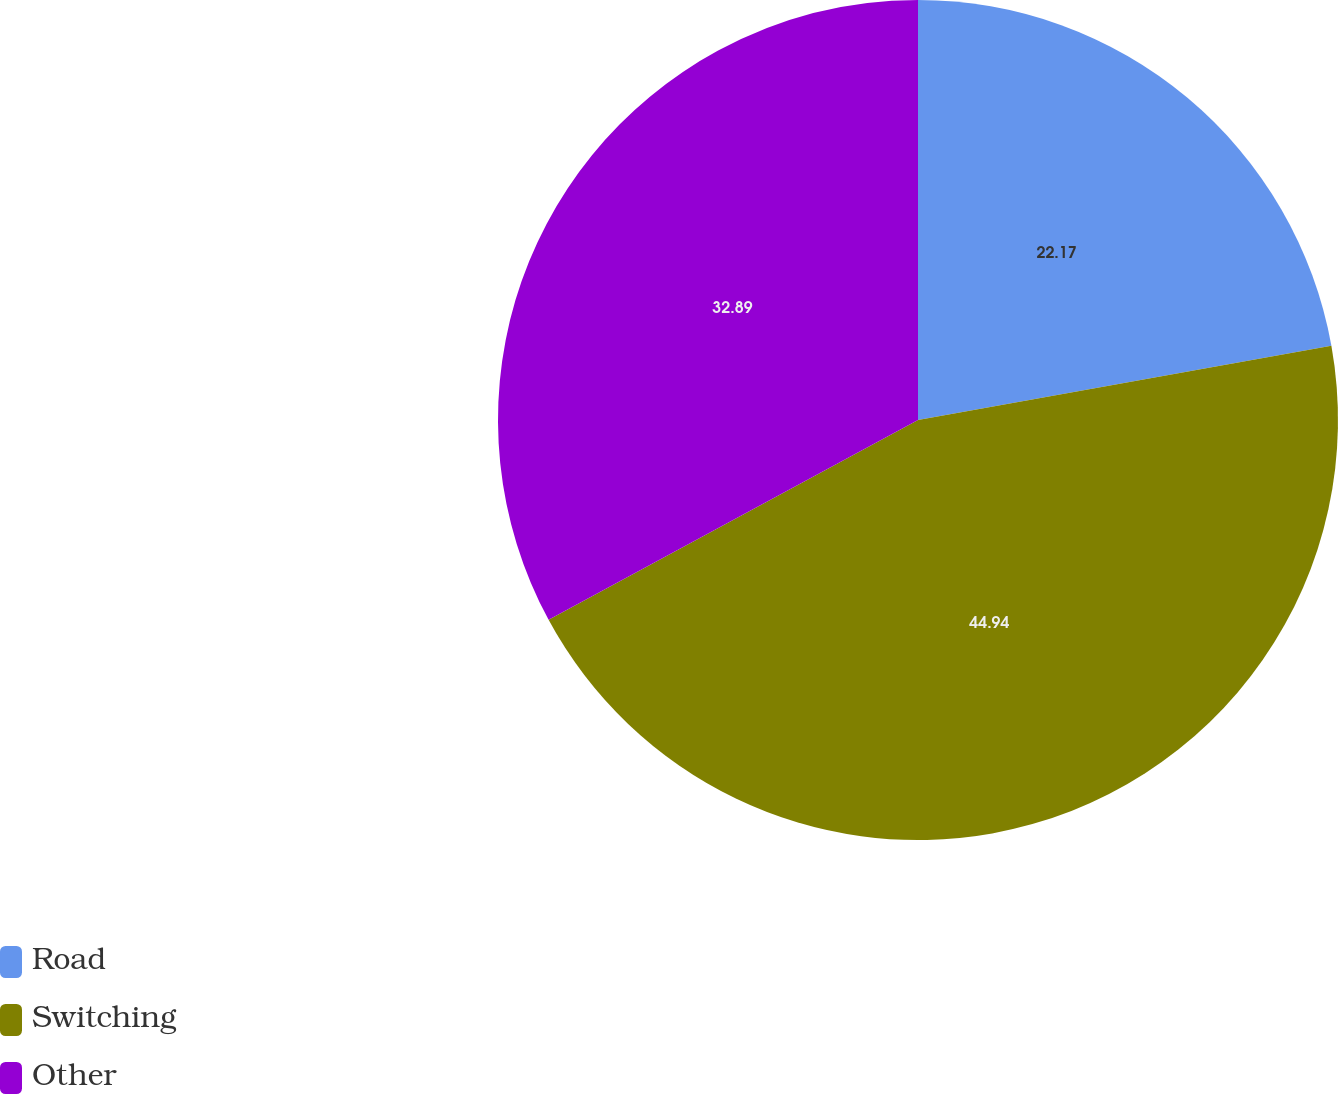<chart> <loc_0><loc_0><loc_500><loc_500><pie_chart><fcel>Road<fcel>Switching<fcel>Other<nl><fcel>22.17%<fcel>44.93%<fcel>32.89%<nl></chart> 